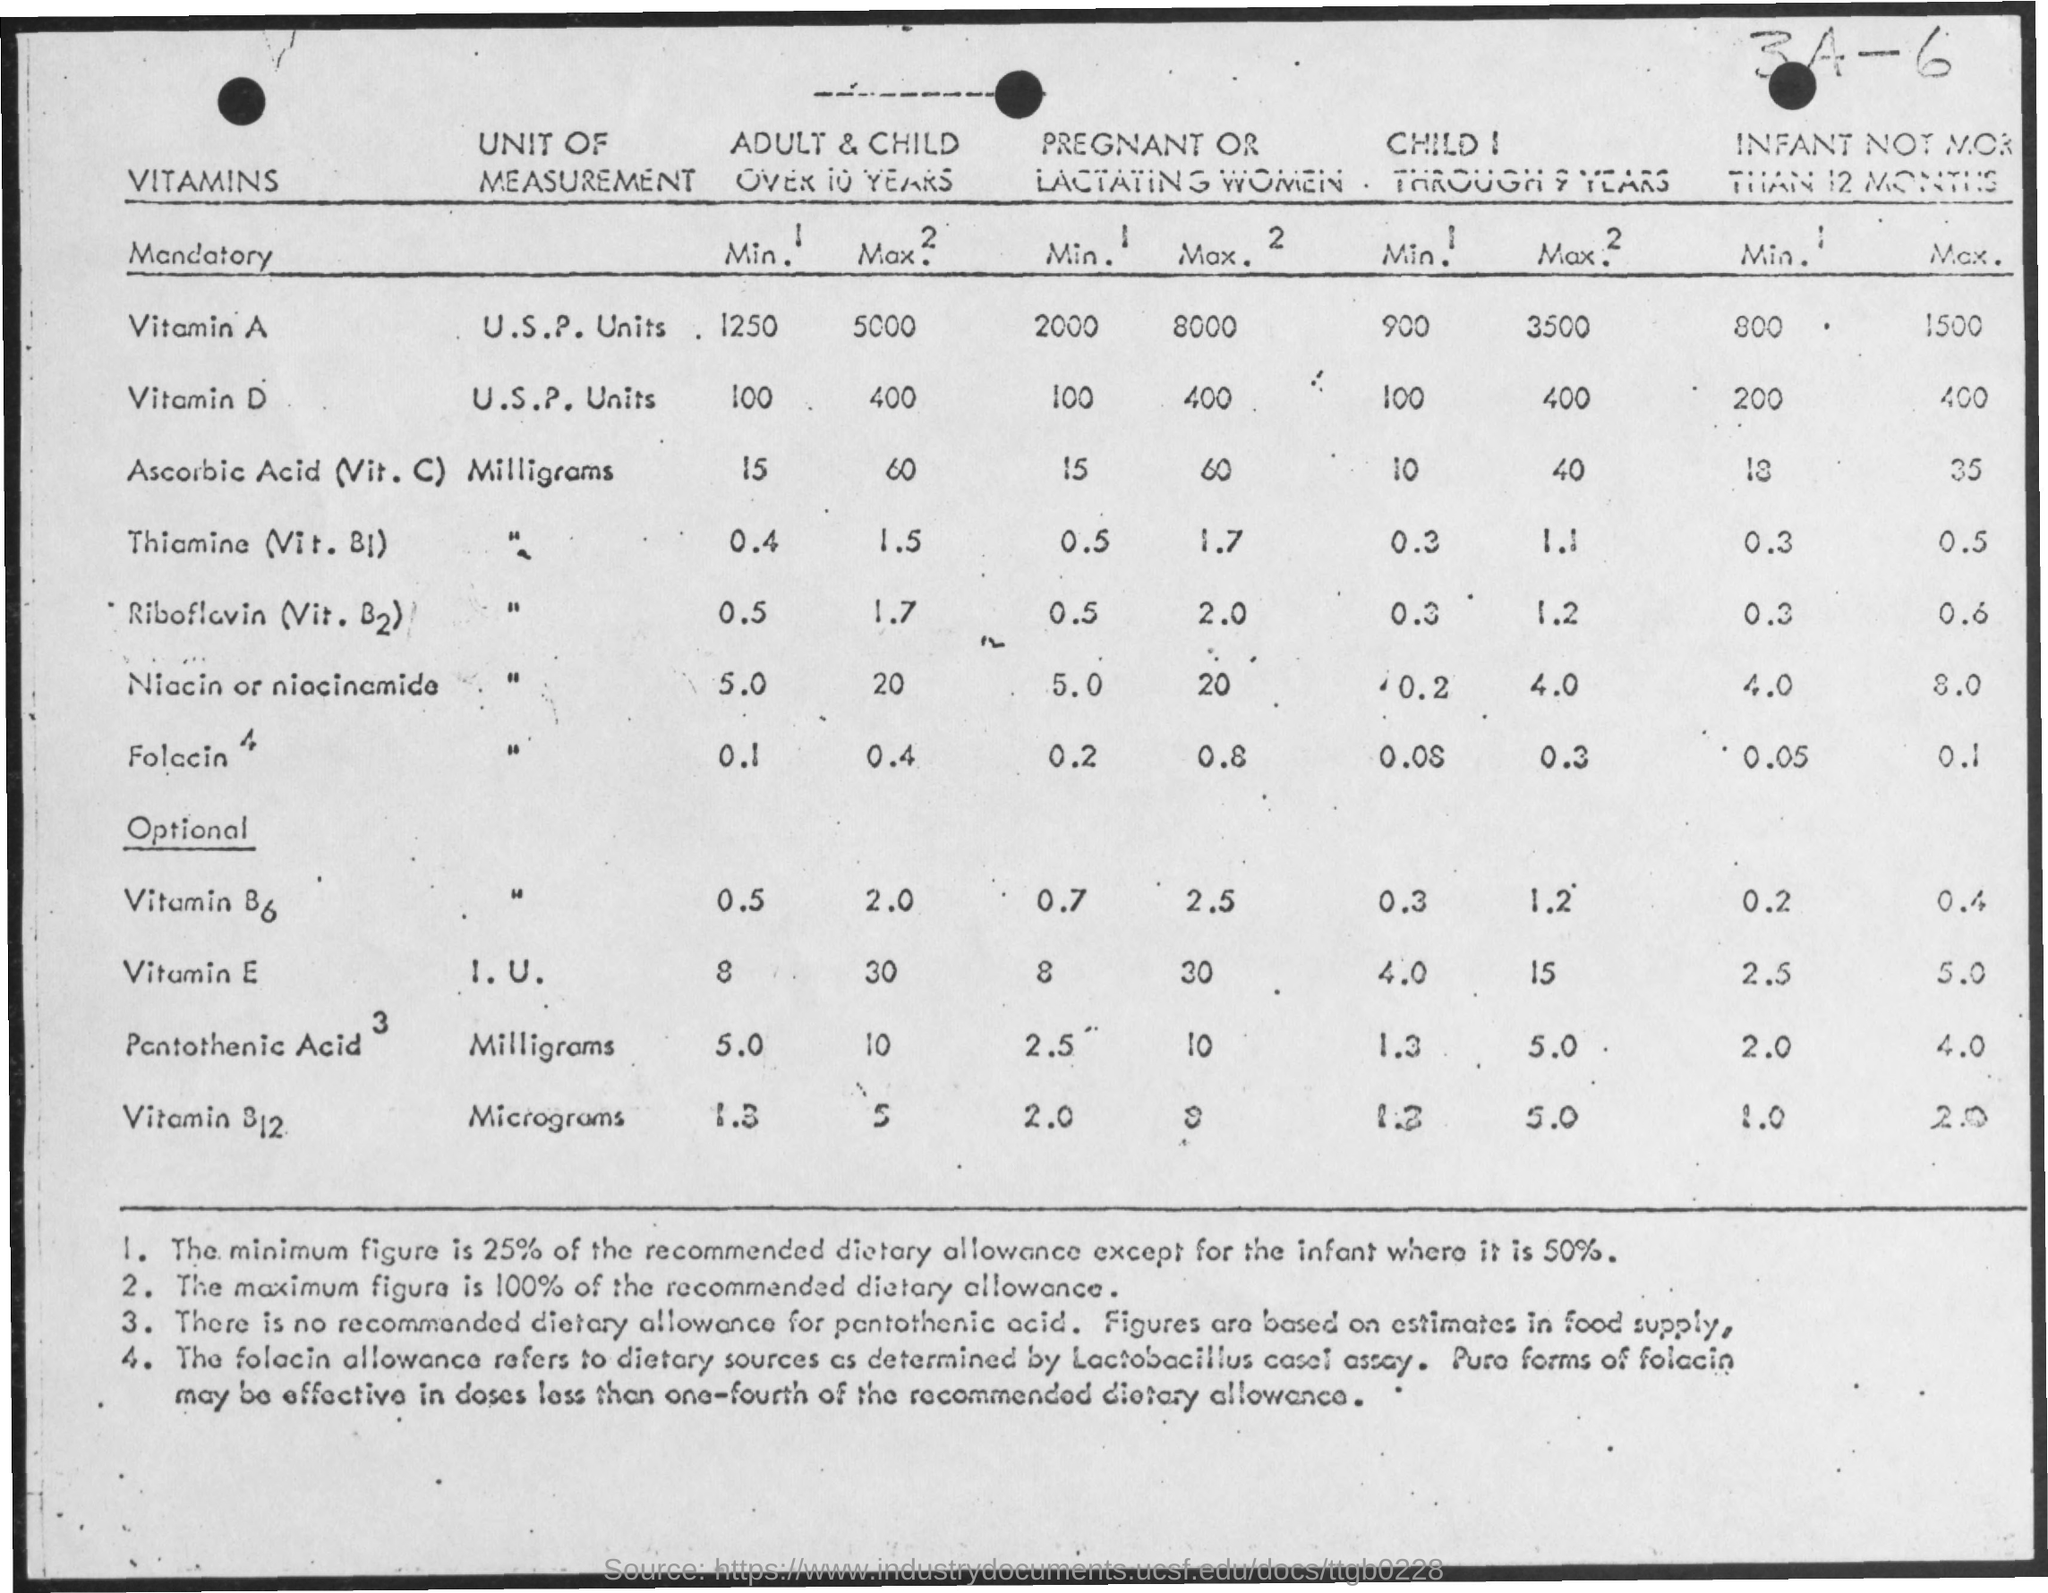Mention a couple of crucial points in this snapshot. Vitamin A is measured in u.s.p. units. Niacin is measured in milligrams. What is the unit of measurement of Vitamin E? It is measured in units, specifically ug (micrograms). The maximum amount of vitamin D recommended for an infant not more than 12 months is 400 international units (IU). The minimum amount of vitamin E recommended for pregnant women is 8 milligrams per day. 